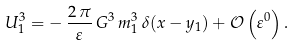<formula> <loc_0><loc_0><loc_500><loc_500>U _ { 1 } ^ { 3 } = - \, \frac { 2 \, \pi } { \varepsilon } \, G ^ { 3 } \, m _ { 1 } ^ { 3 } \, \delta ( x - y _ { 1 } ) + { \mathcal { O } } \left ( \varepsilon ^ { 0 } \right ) .</formula> 